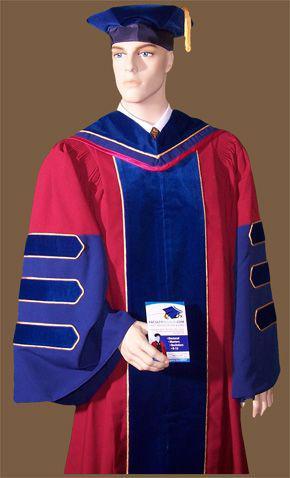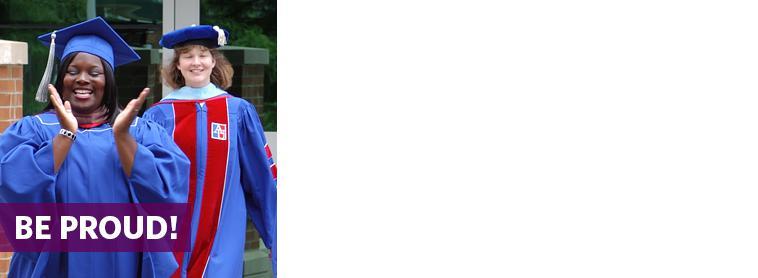The first image is the image on the left, the second image is the image on the right. Analyze the images presented: Is the assertion "All of the graduation caps are blue." valid? Answer yes or no. Yes. The first image is the image on the left, the second image is the image on the right. For the images displayed, is the sentence "Both images contain red and blue." factually correct? Answer yes or no. Yes. 